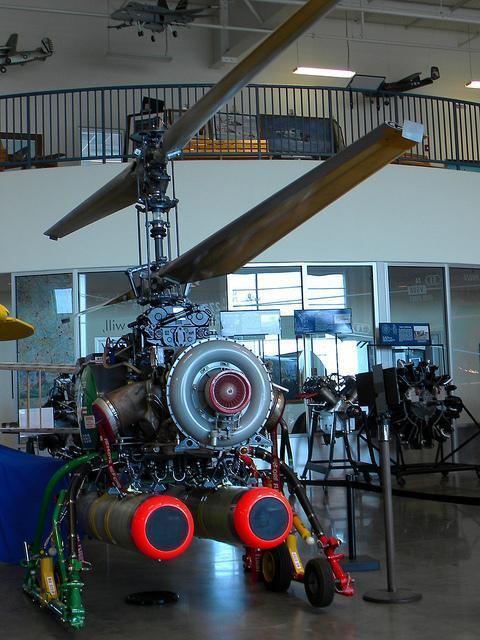How many propellers does the machine have?
Give a very brief answer. 2. How many airplanes are there?
Give a very brief answer. 2. 